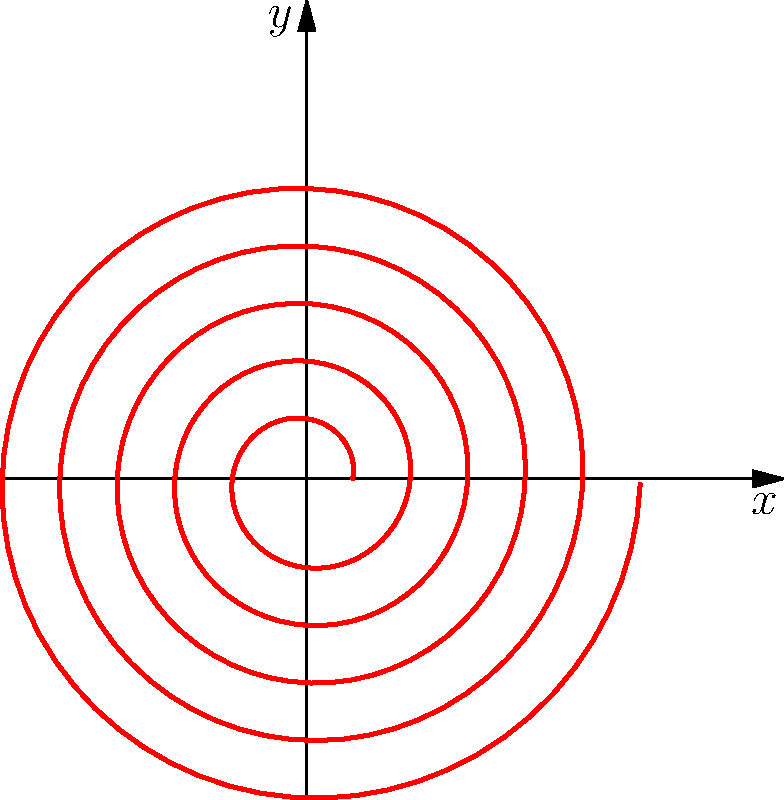In a horror-themed comedy sketch, you want to create a hypnotic spiral pattern. The polar equation for this spiral is given by $r = a + b\theta$, where $a = 0.1$ and $b = 0.02$. If you want the spiral to make exactly 5 complete rotations, what should be the maximum value of $\theta$? To solve this problem, let's break it down step by step:

1) First, recall that one complete rotation in polar coordinates corresponds to an angle of $2\pi$ radians.

2) We want the spiral to make 5 complete rotations, so we need to multiply $2\pi$ by 5:

   $\theta_{max} = 5 \cdot 2\pi$

3) Let's calculate this:
   
   $\theta_{max} = 5 \cdot 2\pi = 10\pi$ radians

4) We can verify this by looking at the graph. The spiral indeed makes 5 complete rotations before stopping.

5) In a comedy sketch, you could humorously point out that this hypnotic spiral might make your audience go round in circles five times before they realize they've been duped!
Answer: $10\pi$ radians 